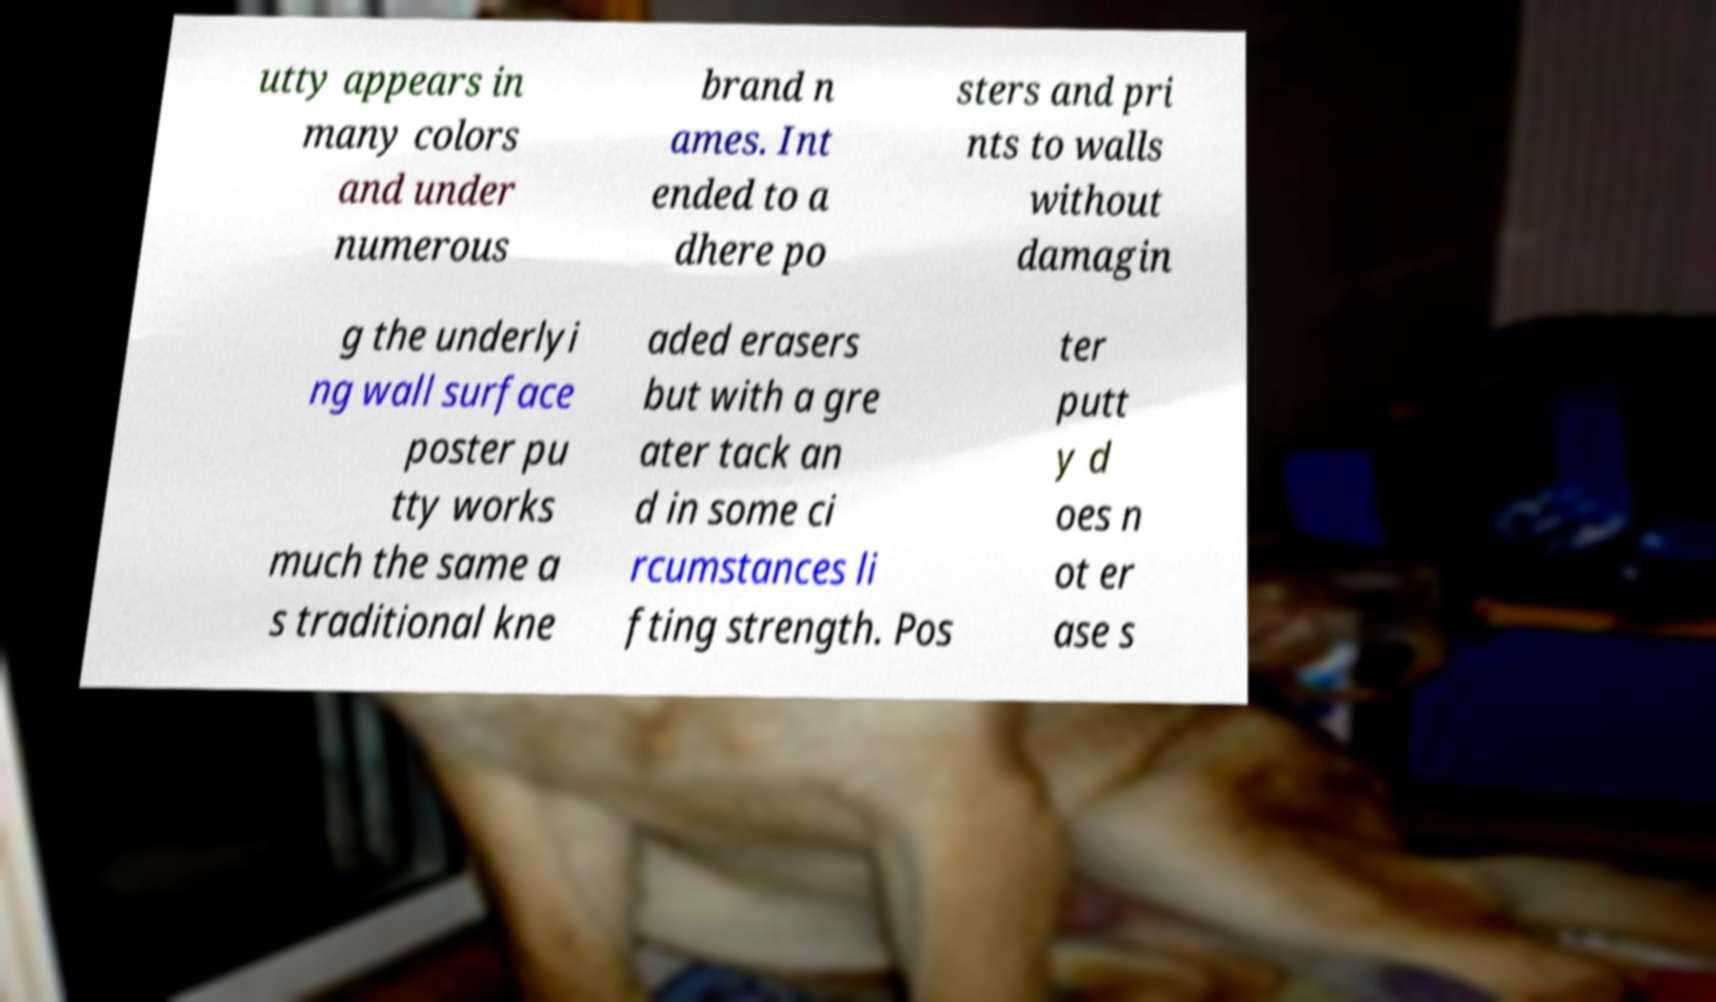Could you extract and type out the text from this image? utty appears in many colors and under numerous brand n ames. Int ended to a dhere po sters and pri nts to walls without damagin g the underlyi ng wall surface poster pu tty works much the same a s traditional kne aded erasers but with a gre ater tack an d in some ci rcumstances li fting strength. Pos ter putt y d oes n ot er ase s 